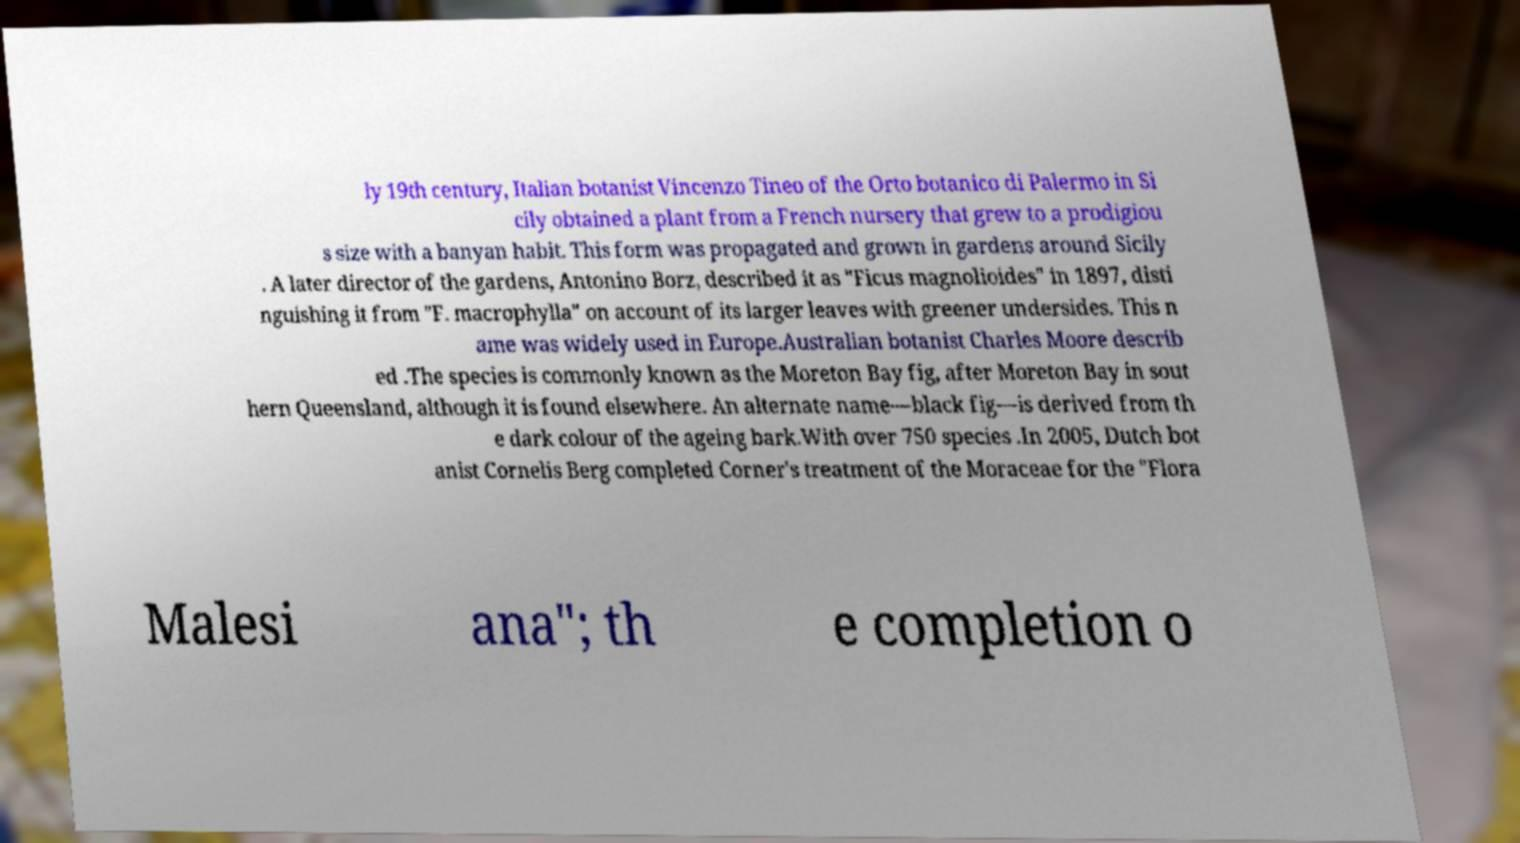I need the written content from this picture converted into text. Can you do that? ly 19th century, Italian botanist Vincenzo Tineo of the Orto botanico di Palermo in Si cily obtained a plant from a French nursery that grew to a prodigiou s size with a banyan habit. This form was propagated and grown in gardens around Sicily . A later director of the gardens, Antonino Borz, described it as "Ficus magnolioides" in 1897, disti nguishing it from "F. macrophylla" on account of its larger leaves with greener undersides. This n ame was widely used in Europe.Australian botanist Charles Moore describ ed .The species is commonly known as the Moreton Bay fig, after Moreton Bay in sout hern Queensland, although it is found elsewhere. An alternate name—black fig—is derived from th e dark colour of the ageing bark.With over 750 species .In 2005, Dutch bot anist Cornelis Berg completed Corner's treatment of the Moraceae for the "Flora Malesi ana"; th e completion o 